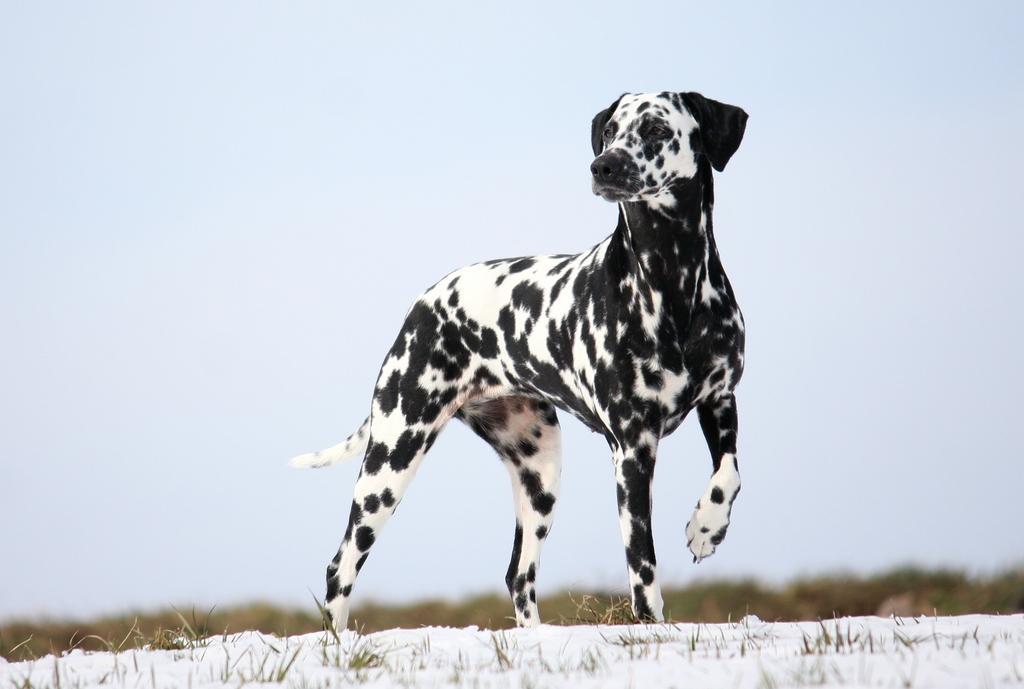What type of animal is on the ground in the image? There is a dog on the ground in the image. What type of terrain is visible in the image? There is grass and snow visible in the image. What can be seen in the background of the image? There are trees and the sky visible in the background of the image. How would you describe the weather in the image? The sky appears cloudy in the image, suggesting a potentially overcast or gloomy day. What type of desk is visible in the image? There is no desk visible in the image; it features a dog, grass, snow, trees, and a cloudy sky. 